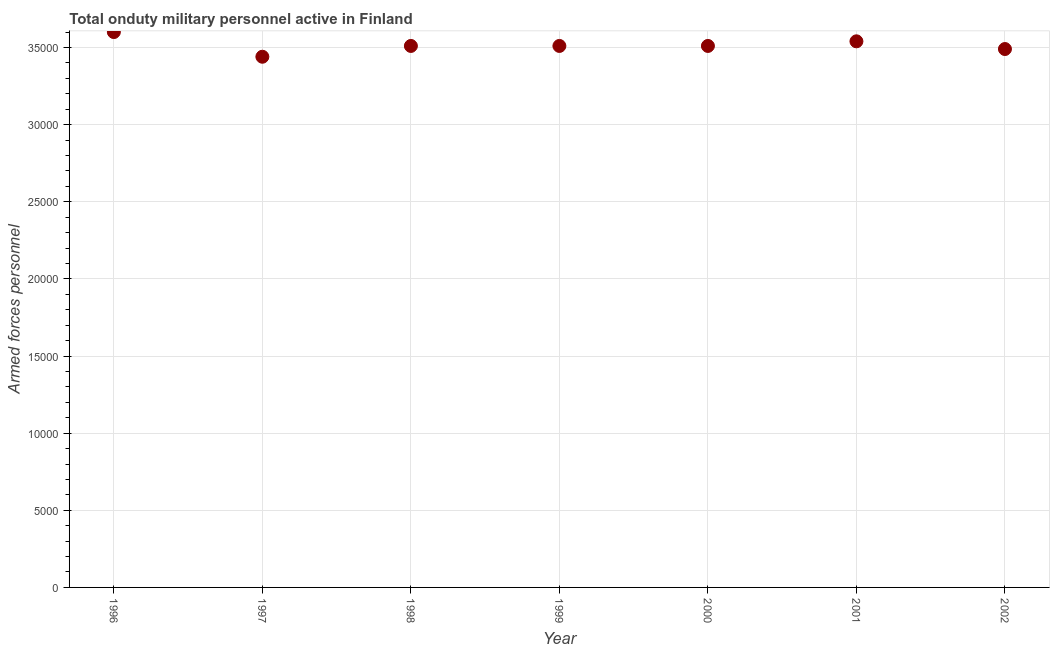What is the number of armed forces personnel in 2000?
Offer a terse response. 3.51e+04. Across all years, what is the maximum number of armed forces personnel?
Keep it short and to the point. 3.60e+04. Across all years, what is the minimum number of armed forces personnel?
Give a very brief answer. 3.44e+04. In which year was the number of armed forces personnel maximum?
Keep it short and to the point. 1996. What is the sum of the number of armed forces personnel?
Offer a terse response. 2.46e+05. What is the difference between the number of armed forces personnel in 1999 and 2002?
Offer a terse response. 200. What is the average number of armed forces personnel per year?
Your response must be concise. 3.51e+04. What is the median number of armed forces personnel?
Provide a short and direct response. 3.51e+04. In how many years, is the number of armed forces personnel greater than 31000 ?
Offer a terse response. 7. Do a majority of the years between 2001 and 1999 (inclusive) have number of armed forces personnel greater than 22000 ?
Your answer should be very brief. No. What is the ratio of the number of armed forces personnel in 1996 to that in 1999?
Offer a very short reply. 1.03. Is the difference between the number of armed forces personnel in 1997 and 1999 greater than the difference between any two years?
Provide a succinct answer. No. What is the difference between the highest and the second highest number of armed forces personnel?
Make the answer very short. 600. What is the difference between the highest and the lowest number of armed forces personnel?
Provide a succinct answer. 1600. In how many years, is the number of armed forces personnel greater than the average number of armed forces personnel taken over all years?
Make the answer very short. 2. Does the number of armed forces personnel monotonically increase over the years?
Provide a succinct answer. No. Does the graph contain any zero values?
Provide a short and direct response. No. What is the title of the graph?
Ensure brevity in your answer.  Total onduty military personnel active in Finland. What is the label or title of the X-axis?
Ensure brevity in your answer.  Year. What is the label or title of the Y-axis?
Ensure brevity in your answer.  Armed forces personnel. What is the Armed forces personnel in 1996?
Make the answer very short. 3.60e+04. What is the Armed forces personnel in 1997?
Offer a terse response. 3.44e+04. What is the Armed forces personnel in 1998?
Offer a very short reply. 3.51e+04. What is the Armed forces personnel in 1999?
Provide a short and direct response. 3.51e+04. What is the Armed forces personnel in 2000?
Make the answer very short. 3.51e+04. What is the Armed forces personnel in 2001?
Provide a succinct answer. 3.54e+04. What is the Armed forces personnel in 2002?
Provide a succinct answer. 3.49e+04. What is the difference between the Armed forces personnel in 1996 and 1997?
Keep it short and to the point. 1600. What is the difference between the Armed forces personnel in 1996 and 1998?
Keep it short and to the point. 900. What is the difference between the Armed forces personnel in 1996 and 1999?
Ensure brevity in your answer.  900. What is the difference between the Armed forces personnel in 1996 and 2000?
Your answer should be compact. 900. What is the difference between the Armed forces personnel in 1996 and 2001?
Give a very brief answer. 600. What is the difference between the Armed forces personnel in 1996 and 2002?
Ensure brevity in your answer.  1100. What is the difference between the Armed forces personnel in 1997 and 1998?
Your answer should be compact. -700. What is the difference between the Armed forces personnel in 1997 and 1999?
Ensure brevity in your answer.  -700. What is the difference between the Armed forces personnel in 1997 and 2000?
Provide a short and direct response. -700. What is the difference between the Armed forces personnel in 1997 and 2001?
Keep it short and to the point. -1000. What is the difference between the Armed forces personnel in 1997 and 2002?
Ensure brevity in your answer.  -500. What is the difference between the Armed forces personnel in 1998 and 1999?
Offer a very short reply. 0. What is the difference between the Armed forces personnel in 1998 and 2000?
Keep it short and to the point. 0. What is the difference between the Armed forces personnel in 1998 and 2001?
Make the answer very short. -300. What is the difference between the Armed forces personnel in 1998 and 2002?
Give a very brief answer. 200. What is the difference between the Armed forces personnel in 1999 and 2001?
Give a very brief answer. -300. What is the difference between the Armed forces personnel in 1999 and 2002?
Your response must be concise. 200. What is the difference between the Armed forces personnel in 2000 and 2001?
Give a very brief answer. -300. What is the ratio of the Armed forces personnel in 1996 to that in 1997?
Give a very brief answer. 1.05. What is the ratio of the Armed forces personnel in 1996 to that in 1999?
Your answer should be compact. 1.03. What is the ratio of the Armed forces personnel in 1996 to that in 2000?
Provide a short and direct response. 1.03. What is the ratio of the Armed forces personnel in 1996 to that in 2002?
Make the answer very short. 1.03. What is the ratio of the Armed forces personnel in 1997 to that in 1999?
Keep it short and to the point. 0.98. What is the ratio of the Armed forces personnel in 1998 to that in 2000?
Ensure brevity in your answer.  1. What is the ratio of the Armed forces personnel in 1998 to that in 2001?
Offer a terse response. 0.99. What is the ratio of the Armed forces personnel in 1999 to that in 2000?
Make the answer very short. 1. What is the ratio of the Armed forces personnel in 1999 to that in 2001?
Make the answer very short. 0.99. What is the ratio of the Armed forces personnel in 1999 to that in 2002?
Provide a succinct answer. 1.01. What is the ratio of the Armed forces personnel in 2000 to that in 2002?
Make the answer very short. 1.01. 